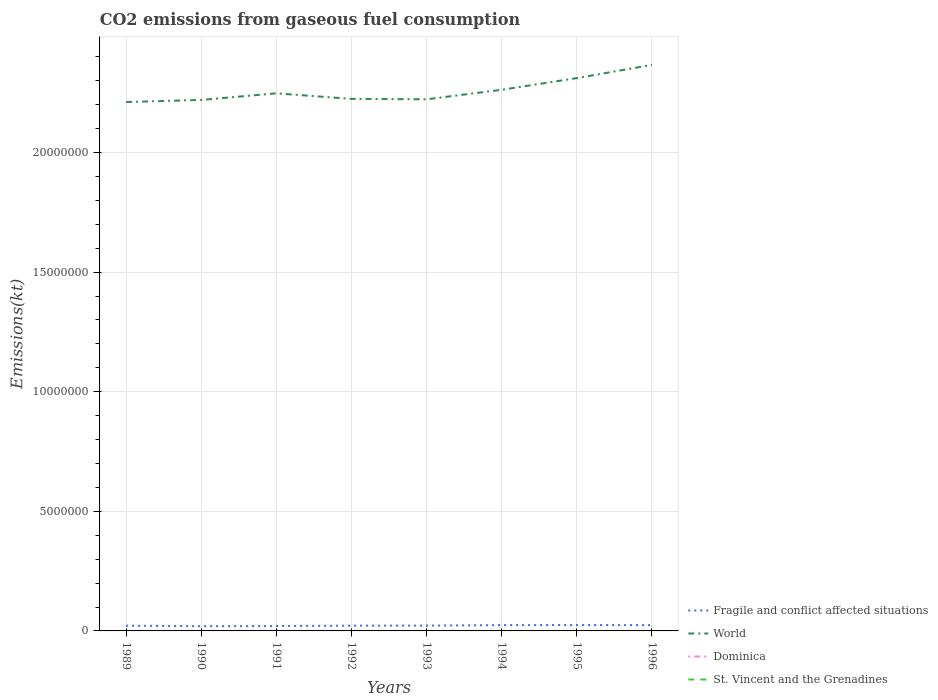How many different coloured lines are there?
Keep it short and to the point. 4. Across all years, what is the maximum amount of CO2 emitted in St. Vincent and the Grenadines?
Provide a short and direct response. 77.01. What is the difference between the highest and the second highest amount of CO2 emitted in Fragile and conflict affected situations?
Your answer should be compact. 4.87e+04. Is the amount of CO2 emitted in Fragile and conflict affected situations strictly greater than the amount of CO2 emitted in World over the years?
Make the answer very short. Yes. How many lines are there?
Make the answer very short. 4. How many years are there in the graph?
Give a very brief answer. 8. How are the legend labels stacked?
Offer a very short reply. Vertical. What is the title of the graph?
Ensure brevity in your answer.  CO2 emissions from gaseous fuel consumption. Does "France" appear as one of the legend labels in the graph?
Your answer should be compact. No. What is the label or title of the X-axis?
Your answer should be very brief. Years. What is the label or title of the Y-axis?
Offer a very short reply. Emissions(kt). What is the Emissions(kt) in Fragile and conflict affected situations in 1989?
Offer a very short reply. 2.19e+05. What is the Emissions(kt) of World in 1989?
Ensure brevity in your answer.  2.21e+07. What is the Emissions(kt) in Dominica in 1989?
Ensure brevity in your answer.  58.67. What is the Emissions(kt) in St. Vincent and the Grenadines in 1989?
Ensure brevity in your answer.  77.01. What is the Emissions(kt) in Fragile and conflict affected situations in 1990?
Provide a short and direct response. 1.97e+05. What is the Emissions(kt) in World in 1990?
Your answer should be compact. 2.22e+07. What is the Emissions(kt) of Dominica in 1990?
Make the answer very short. 58.67. What is the Emissions(kt) of St. Vincent and the Grenadines in 1990?
Offer a terse response. 80.67. What is the Emissions(kt) of Fragile and conflict affected situations in 1991?
Offer a terse response. 2.04e+05. What is the Emissions(kt) of World in 1991?
Your response must be concise. 2.25e+07. What is the Emissions(kt) of Dominica in 1991?
Offer a very short reply. 58.67. What is the Emissions(kt) of St. Vincent and the Grenadines in 1991?
Keep it short and to the point. 77.01. What is the Emissions(kt) in Fragile and conflict affected situations in 1992?
Your answer should be very brief. 2.19e+05. What is the Emissions(kt) of World in 1992?
Make the answer very short. 2.22e+07. What is the Emissions(kt) in Dominica in 1992?
Offer a terse response. 58.67. What is the Emissions(kt) in St. Vincent and the Grenadines in 1992?
Give a very brief answer. 84.34. What is the Emissions(kt) in Fragile and conflict affected situations in 1993?
Your response must be concise. 2.22e+05. What is the Emissions(kt) in World in 1993?
Your response must be concise. 2.22e+07. What is the Emissions(kt) in Dominica in 1993?
Offer a terse response. 62.34. What is the Emissions(kt) of St. Vincent and the Grenadines in 1993?
Keep it short and to the point. 102.68. What is the Emissions(kt) of Fragile and conflict affected situations in 1994?
Your answer should be compact. 2.43e+05. What is the Emissions(kt) in World in 1994?
Keep it short and to the point. 2.26e+07. What is the Emissions(kt) in Dominica in 1994?
Give a very brief answer. 69.67. What is the Emissions(kt) in St. Vincent and the Grenadines in 1994?
Give a very brief answer. 121.01. What is the Emissions(kt) of Fragile and conflict affected situations in 1995?
Make the answer very short. 2.46e+05. What is the Emissions(kt) of World in 1995?
Your answer should be very brief. 2.31e+07. What is the Emissions(kt) in Dominica in 1995?
Provide a short and direct response. 80.67. What is the Emissions(kt) in St. Vincent and the Grenadines in 1995?
Your response must be concise. 128.34. What is the Emissions(kt) in Fragile and conflict affected situations in 1996?
Provide a succinct answer. 2.42e+05. What is the Emissions(kt) in World in 1996?
Provide a succinct answer. 2.37e+07. What is the Emissions(kt) in Dominica in 1996?
Provide a succinct answer. 73.34. What is the Emissions(kt) in St. Vincent and the Grenadines in 1996?
Keep it short and to the point. 132.01. Across all years, what is the maximum Emissions(kt) in Fragile and conflict affected situations?
Your response must be concise. 2.46e+05. Across all years, what is the maximum Emissions(kt) of World?
Your answer should be very brief. 2.37e+07. Across all years, what is the maximum Emissions(kt) of Dominica?
Your response must be concise. 80.67. Across all years, what is the maximum Emissions(kt) of St. Vincent and the Grenadines?
Offer a very short reply. 132.01. Across all years, what is the minimum Emissions(kt) of Fragile and conflict affected situations?
Give a very brief answer. 1.97e+05. Across all years, what is the minimum Emissions(kt) of World?
Make the answer very short. 2.21e+07. Across all years, what is the minimum Emissions(kt) in Dominica?
Ensure brevity in your answer.  58.67. Across all years, what is the minimum Emissions(kt) in St. Vincent and the Grenadines?
Offer a very short reply. 77.01. What is the total Emissions(kt) of Fragile and conflict affected situations in the graph?
Offer a very short reply. 1.79e+06. What is the total Emissions(kt) in World in the graph?
Provide a short and direct response. 1.81e+08. What is the total Emissions(kt) in Dominica in the graph?
Provide a succinct answer. 520.71. What is the total Emissions(kt) of St. Vincent and the Grenadines in the graph?
Your answer should be compact. 803.07. What is the difference between the Emissions(kt) of Fragile and conflict affected situations in 1989 and that in 1990?
Give a very brief answer. 2.20e+04. What is the difference between the Emissions(kt) in World in 1989 and that in 1990?
Make the answer very short. -8.86e+04. What is the difference between the Emissions(kt) in Dominica in 1989 and that in 1990?
Offer a terse response. 0. What is the difference between the Emissions(kt) of St. Vincent and the Grenadines in 1989 and that in 1990?
Offer a terse response. -3.67. What is the difference between the Emissions(kt) in Fragile and conflict affected situations in 1989 and that in 1991?
Your answer should be compact. 1.46e+04. What is the difference between the Emissions(kt) of World in 1989 and that in 1991?
Keep it short and to the point. -3.65e+05. What is the difference between the Emissions(kt) in Dominica in 1989 and that in 1991?
Keep it short and to the point. 0. What is the difference between the Emissions(kt) in St. Vincent and the Grenadines in 1989 and that in 1991?
Ensure brevity in your answer.  0. What is the difference between the Emissions(kt) in Fragile and conflict affected situations in 1989 and that in 1992?
Your answer should be compact. -659.5. What is the difference between the Emissions(kt) in World in 1989 and that in 1992?
Provide a short and direct response. -1.33e+05. What is the difference between the Emissions(kt) of Dominica in 1989 and that in 1992?
Your response must be concise. 0. What is the difference between the Emissions(kt) of St. Vincent and the Grenadines in 1989 and that in 1992?
Give a very brief answer. -7.33. What is the difference between the Emissions(kt) of Fragile and conflict affected situations in 1989 and that in 1993?
Give a very brief answer. -3215.98. What is the difference between the Emissions(kt) in World in 1989 and that in 1993?
Ensure brevity in your answer.  -1.15e+05. What is the difference between the Emissions(kt) of Dominica in 1989 and that in 1993?
Keep it short and to the point. -3.67. What is the difference between the Emissions(kt) of St. Vincent and the Grenadines in 1989 and that in 1993?
Keep it short and to the point. -25.67. What is the difference between the Emissions(kt) in Fragile and conflict affected situations in 1989 and that in 1994?
Give a very brief answer. -2.40e+04. What is the difference between the Emissions(kt) of World in 1989 and that in 1994?
Your response must be concise. -5.14e+05. What is the difference between the Emissions(kt) of Dominica in 1989 and that in 1994?
Offer a very short reply. -11. What is the difference between the Emissions(kt) of St. Vincent and the Grenadines in 1989 and that in 1994?
Offer a very short reply. -44. What is the difference between the Emissions(kt) of Fragile and conflict affected situations in 1989 and that in 1995?
Your answer should be compact. -2.67e+04. What is the difference between the Emissions(kt) of World in 1989 and that in 1995?
Your response must be concise. -1.00e+06. What is the difference between the Emissions(kt) of Dominica in 1989 and that in 1995?
Provide a succinct answer. -22. What is the difference between the Emissions(kt) in St. Vincent and the Grenadines in 1989 and that in 1995?
Ensure brevity in your answer.  -51.34. What is the difference between the Emissions(kt) in Fragile and conflict affected situations in 1989 and that in 1996?
Your answer should be very brief. -2.31e+04. What is the difference between the Emissions(kt) in World in 1989 and that in 1996?
Provide a short and direct response. -1.55e+06. What is the difference between the Emissions(kt) in Dominica in 1989 and that in 1996?
Offer a very short reply. -14.67. What is the difference between the Emissions(kt) of St. Vincent and the Grenadines in 1989 and that in 1996?
Make the answer very short. -55.01. What is the difference between the Emissions(kt) in Fragile and conflict affected situations in 1990 and that in 1991?
Make the answer very short. -7327.05. What is the difference between the Emissions(kt) in World in 1990 and that in 1991?
Make the answer very short. -2.76e+05. What is the difference between the Emissions(kt) of St. Vincent and the Grenadines in 1990 and that in 1991?
Provide a succinct answer. 3.67. What is the difference between the Emissions(kt) in Fragile and conflict affected situations in 1990 and that in 1992?
Offer a terse response. -2.26e+04. What is the difference between the Emissions(kt) of World in 1990 and that in 1992?
Make the answer very short. -4.44e+04. What is the difference between the Emissions(kt) in St. Vincent and the Grenadines in 1990 and that in 1992?
Make the answer very short. -3.67. What is the difference between the Emissions(kt) in Fragile and conflict affected situations in 1990 and that in 1993?
Offer a terse response. -2.52e+04. What is the difference between the Emissions(kt) in World in 1990 and that in 1993?
Ensure brevity in your answer.  -2.67e+04. What is the difference between the Emissions(kt) in Dominica in 1990 and that in 1993?
Provide a short and direct response. -3.67. What is the difference between the Emissions(kt) of St. Vincent and the Grenadines in 1990 and that in 1993?
Give a very brief answer. -22. What is the difference between the Emissions(kt) of Fragile and conflict affected situations in 1990 and that in 1994?
Provide a short and direct response. -4.60e+04. What is the difference between the Emissions(kt) of World in 1990 and that in 1994?
Your answer should be very brief. -4.25e+05. What is the difference between the Emissions(kt) of Dominica in 1990 and that in 1994?
Keep it short and to the point. -11. What is the difference between the Emissions(kt) in St. Vincent and the Grenadines in 1990 and that in 1994?
Your answer should be very brief. -40.34. What is the difference between the Emissions(kt) in Fragile and conflict affected situations in 1990 and that in 1995?
Your answer should be compact. -4.87e+04. What is the difference between the Emissions(kt) of World in 1990 and that in 1995?
Keep it short and to the point. -9.13e+05. What is the difference between the Emissions(kt) in Dominica in 1990 and that in 1995?
Provide a succinct answer. -22. What is the difference between the Emissions(kt) of St. Vincent and the Grenadines in 1990 and that in 1995?
Ensure brevity in your answer.  -47.67. What is the difference between the Emissions(kt) of Fragile and conflict affected situations in 1990 and that in 1996?
Your answer should be very brief. -4.50e+04. What is the difference between the Emissions(kt) in World in 1990 and that in 1996?
Offer a very short reply. -1.47e+06. What is the difference between the Emissions(kt) in Dominica in 1990 and that in 1996?
Make the answer very short. -14.67. What is the difference between the Emissions(kt) in St. Vincent and the Grenadines in 1990 and that in 1996?
Your answer should be very brief. -51.34. What is the difference between the Emissions(kt) in Fragile and conflict affected situations in 1991 and that in 1992?
Provide a short and direct response. -1.53e+04. What is the difference between the Emissions(kt) in World in 1991 and that in 1992?
Provide a succinct answer. 2.32e+05. What is the difference between the Emissions(kt) in St. Vincent and the Grenadines in 1991 and that in 1992?
Provide a succinct answer. -7.33. What is the difference between the Emissions(kt) in Fragile and conflict affected situations in 1991 and that in 1993?
Keep it short and to the point. -1.79e+04. What is the difference between the Emissions(kt) in World in 1991 and that in 1993?
Your response must be concise. 2.49e+05. What is the difference between the Emissions(kt) in Dominica in 1991 and that in 1993?
Your answer should be compact. -3.67. What is the difference between the Emissions(kt) in St. Vincent and the Grenadines in 1991 and that in 1993?
Provide a short and direct response. -25.67. What is the difference between the Emissions(kt) in Fragile and conflict affected situations in 1991 and that in 1994?
Make the answer very short. -3.86e+04. What is the difference between the Emissions(kt) in World in 1991 and that in 1994?
Your answer should be very brief. -1.49e+05. What is the difference between the Emissions(kt) of Dominica in 1991 and that in 1994?
Ensure brevity in your answer.  -11. What is the difference between the Emissions(kt) in St. Vincent and the Grenadines in 1991 and that in 1994?
Your answer should be very brief. -44. What is the difference between the Emissions(kt) in Fragile and conflict affected situations in 1991 and that in 1995?
Keep it short and to the point. -4.14e+04. What is the difference between the Emissions(kt) in World in 1991 and that in 1995?
Give a very brief answer. -6.37e+05. What is the difference between the Emissions(kt) of Dominica in 1991 and that in 1995?
Your answer should be compact. -22. What is the difference between the Emissions(kt) of St. Vincent and the Grenadines in 1991 and that in 1995?
Provide a succinct answer. -51.34. What is the difference between the Emissions(kt) in Fragile and conflict affected situations in 1991 and that in 1996?
Your answer should be compact. -3.77e+04. What is the difference between the Emissions(kt) of World in 1991 and that in 1996?
Your answer should be very brief. -1.19e+06. What is the difference between the Emissions(kt) in Dominica in 1991 and that in 1996?
Offer a terse response. -14.67. What is the difference between the Emissions(kt) in St. Vincent and the Grenadines in 1991 and that in 1996?
Keep it short and to the point. -55.01. What is the difference between the Emissions(kt) of Fragile and conflict affected situations in 1992 and that in 1993?
Ensure brevity in your answer.  -2556.47. What is the difference between the Emissions(kt) in World in 1992 and that in 1993?
Keep it short and to the point. 1.77e+04. What is the difference between the Emissions(kt) of Dominica in 1992 and that in 1993?
Your answer should be compact. -3.67. What is the difference between the Emissions(kt) in St. Vincent and the Grenadines in 1992 and that in 1993?
Give a very brief answer. -18.34. What is the difference between the Emissions(kt) in Fragile and conflict affected situations in 1992 and that in 1994?
Give a very brief answer. -2.33e+04. What is the difference between the Emissions(kt) of World in 1992 and that in 1994?
Ensure brevity in your answer.  -3.81e+05. What is the difference between the Emissions(kt) in Dominica in 1992 and that in 1994?
Provide a short and direct response. -11. What is the difference between the Emissions(kt) in St. Vincent and the Grenadines in 1992 and that in 1994?
Your answer should be compact. -36.67. What is the difference between the Emissions(kt) in Fragile and conflict affected situations in 1992 and that in 1995?
Your response must be concise. -2.61e+04. What is the difference between the Emissions(kt) of World in 1992 and that in 1995?
Keep it short and to the point. -8.69e+05. What is the difference between the Emissions(kt) of Dominica in 1992 and that in 1995?
Make the answer very short. -22. What is the difference between the Emissions(kt) in St. Vincent and the Grenadines in 1992 and that in 1995?
Offer a very short reply. -44. What is the difference between the Emissions(kt) of Fragile and conflict affected situations in 1992 and that in 1996?
Offer a terse response. -2.24e+04. What is the difference between the Emissions(kt) in World in 1992 and that in 1996?
Make the answer very short. -1.42e+06. What is the difference between the Emissions(kt) in Dominica in 1992 and that in 1996?
Provide a short and direct response. -14.67. What is the difference between the Emissions(kt) in St. Vincent and the Grenadines in 1992 and that in 1996?
Offer a very short reply. -47.67. What is the difference between the Emissions(kt) of Fragile and conflict affected situations in 1993 and that in 1994?
Give a very brief answer. -2.08e+04. What is the difference between the Emissions(kt) in World in 1993 and that in 1994?
Give a very brief answer. -3.99e+05. What is the difference between the Emissions(kt) of Dominica in 1993 and that in 1994?
Offer a very short reply. -7.33. What is the difference between the Emissions(kt) in St. Vincent and the Grenadines in 1993 and that in 1994?
Offer a very short reply. -18.34. What is the difference between the Emissions(kt) of Fragile and conflict affected situations in 1993 and that in 1995?
Offer a terse response. -2.35e+04. What is the difference between the Emissions(kt) in World in 1993 and that in 1995?
Your answer should be compact. -8.87e+05. What is the difference between the Emissions(kt) of Dominica in 1993 and that in 1995?
Your response must be concise. -18.34. What is the difference between the Emissions(kt) of St. Vincent and the Grenadines in 1993 and that in 1995?
Provide a succinct answer. -25.67. What is the difference between the Emissions(kt) in Fragile and conflict affected situations in 1993 and that in 1996?
Your response must be concise. -1.99e+04. What is the difference between the Emissions(kt) in World in 1993 and that in 1996?
Your response must be concise. -1.44e+06. What is the difference between the Emissions(kt) of Dominica in 1993 and that in 1996?
Provide a short and direct response. -11. What is the difference between the Emissions(kt) of St. Vincent and the Grenadines in 1993 and that in 1996?
Make the answer very short. -29.34. What is the difference between the Emissions(kt) of Fragile and conflict affected situations in 1994 and that in 1995?
Provide a succinct answer. -2730.08. What is the difference between the Emissions(kt) of World in 1994 and that in 1995?
Offer a very short reply. -4.88e+05. What is the difference between the Emissions(kt) in Dominica in 1994 and that in 1995?
Your answer should be compact. -11. What is the difference between the Emissions(kt) of St. Vincent and the Grenadines in 1994 and that in 1995?
Provide a succinct answer. -7.33. What is the difference between the Emissions(kt) in Fragile and conflict affected situations in 1994 and that in 1996?
Give a very brief answer. 925.17. What is the difference between the Emissions(kt) of World in 1994 and that in 1996?
Keep it short and to the point. -1.04e+06. What is the difference between the Emissions(kt) in Dominica in 1994 and that in 1996?
Offer a terse response. -3.67. What is the difference between the Emissions(kt) in St. Vincent and the Grenadines in 1994 and that in 1996?
Your answer should be compact. -11. What is the difference between the Emissions(kt) in Fragile and conflict affected situations in 1995 and that in 1996?
Your answer should be compact. 3655.26. What is the difference between the Emissions(kt) of World in 1995 and that in 1996?
Provide a succinct answer. -5.53e+05. What is the difference between the Emissions(kt) of Dominica in 1995 and that in 1996?
Your answer should be compact. 7.33. What is the difference between the Emissions(kt) in St. Vincent and the Grenadines in 1995 and that in 1996?
Provide a succinct answer. -3.67. What is the difference between the Emissions(kt) of Fragile and conflict affected situations in 1989 and the Emissions(kt) of World in 1990?
Make the answer very short. -2.20e+07. What is the difference between the Emissions(kt) in Fragile and conflict affected situations in 1989 and the Emissions(kt) in Dominica in 1990?
Keep it short and to the point. 2.19e+05. What is the difference between the Emissions(kt) of Fragile and conflict affected situations in 1989 and the Emissions(kt) of St. Vincent and the Grenadines in 1990?
Keep it short and to the point. 2.19e+05. What is the difference between the Emissions(kt) of World in 1989 and the Emissions(kt) of Dominica in 1990?
Give a very brief answer. 2.21e+07. What is the difference between the Emissions(kt) in World in 1989 and the Emissions(kt) in St. Vincent and the Grenadines in 1990?
Keep it short and to the point. 2.21e+07. What is the difference between the Emissions(kt) of Dominica in 1989 and the Emissions(kt) of St. Vincent and the Grenadines in 1990?
Your response must be concise. -22. What is the difference between the Emissions(kt) in Fragile and conflict affected situations in 1989 and the Emissions(kt) in World in 1991?
Ensure brevity in your answer.  -2.23e+07. What is the difference between the Emissions(kt) in Fragile and conflict affected situations in 1989 and the Emissions(kt) in Dominica in 1991?
Your answer should be very brief. 2.19e+05. What is the difference between the Emissions(kt) in Fragile and conflict affected situations in 1989 and the Emissions(kt) in St. Vincent and the Grenadines in 1991?
Give a very brief answer. 2.19e+05. What is the difference between the Emissions(kt) of World in 1989 and the Emissions(kt) of Dominica in 1991?
Your response must be concise. 2.21e+07. What is the difference between the Emissions(kt) in World in 1989 and the Emissions(kt) in St. Vincent and the Grenadines in 1991?
Your response must be concise. 2.21e+07. What is the difference between the Emissions(kt) of Dominica in 1989 and the Emissions(kt) of St. Vincent and the Grenadines in 1991?
Give a very brief answer. -18.34. What is the difference between the Emissions(kt) in Fragile and conflict affected situations in 1989 and the Emissions(kt) in World in 1992?
Ensure brevity in your answer.  -2.20e+07. What is the difference between the Emissions(kt) of Fragile and conflict affected situations in 1989 and the Emissions(kt) of Dominica in 1992?
Keep it short and to the point. 2.19e+05. What is the difference between the Emissions(kt) in Fragile and conflict affected situations in 1989 and the Emissions(kt) in St. Vincent and the Grenadines in 1992?
Ensure brevity in your answer.  2.19e+05. What is the difference between the Emissions(kt) of World in 1989 and the Emissions(kt) of Dominica in 1992?
Provide a short and direct response. 2.21e+07. What is the difference between the Emissions(kt) in World in 1989 and the Emissions(kt) in St. Vincent and the Grenadines in 1992?
Provide a succinct answer. 2.21e+07. What is the difference between the Emissions(kt) in Dominica in 1989 and the Emissions(kt) in St. Vincent and the Grenadines in 1992?
Your response must be concise. -25.67. What is the difference between the Emissions(kt) of Fragile and conflict affected situations in 1989 and the Emissions(kt) of World in 1993?
Keep it short and to the point. -2.20e+07. What is the difference between the Emissions(kt) of Fragile and conflict affected situations in 1989 and the Emissions(kt) of Dominica in 1993?
Give a very brief answer. 2.19e+05. What is the difference between the Emissions(kt) in Fragile and conflict affected situations in 1989 and the Emissions(kt) in St. Vincent and the Grenadines in 1993?
Your answer should be very brief. 2.19e+05. What is the difference between the Emissions(kt) of World in 1989 and the Emissions(kt) of Dominica in 1993?
Offer a terse response. 2.21e+07. What is the difference between the Emissions(kt) in World in 1989 and the Emissions(kt) in St. Vincent and the Grenadines in 1993?
Your response must be concise. 2.21e+07. What is the difference between the Emissions(kt) in Dominica in 1989 and the Emissions(kt) in St. Vincent and the Grenadines in 1993?
Your answer should be very brief. -44. What is the difference between the Emissions(kt) of Fragile and conflict affected situations in 1989 and the Emissions(kt) of World in 1994?
Your response must be concise. -2.24e+07. What is the difference between the Emissions(kt) of Fragile and conflict affected situations in 1989 and the Emissions(kt) of Dominica in 1994?
Offer a terse response. 2.19e+05. What is the difference between the Emissions(kt) in Fragile and conflict affected situations in 1989 and the Emissions(kt) in St. Vincent and the Grenadines in 1994?
Ensure brevity in your answer.  2.19e+05. What is the difference between the Emissions(kt) of World in 1989 and the Emissions(kt) of Dominica in 1994?
Offer a terse response. 2.21e+07. What is the difference between the Emissions(kt) of World in 1989 and the Emissions(kt) of St. Vincent and the Grenadines in 1994?
Provide a succinct answer. 2.21e+07. What is the difference between the Emissions(kt) in Dominica in 1989 and the Emissions(kt) in St. Vincent and the Grenadines in 1994?
Your answer should be very brief. -62.34. What is the difference between the Emissions(kt) in Fragile and conflict affected situations in 1989 and the Emissions(kt) in World in 1995?
Give a very brief answer. -2.29e+07. What is the difference between the Emissions(kt) in Fragile and conflict affected situations in 1989 and the Emissions(kt) in Dominica in 1995?
Provide a short and direct response. 2.19e+05. What is the difference between the Emissions(kt) in Fragile and conflict affected situations in 1989 and the Emissions(kt) in St. Vincent and the Grenadines in 1995?
Provide a succinct answer. 2.19e+05. What is the difference between the Emissions(kt) in World in 1989 and the Emissions(kt) in Dominica in 1995?
Make the answer very short. 2.21e+07. What is the difference between the Emissions(kt) of World in 1989 and the Emissions(kt) of St. Vincent and the Grenadines in 1995?
Keep it short and to the point. 2.21e+07. What is the difference between the Emissions(kt) in Dominica in 1989 and the Emissions(kt) in St. Vincent and the Grenadines in 1995?
Ensure brevity in your answer.  -69.67. What is the difference between the Emissions(kt) of Fragile and conflict affected situations in 1989 and the Emissions(kt) of World in 1996?
Offer a terse response. -2.34e+07. What is the difference between the Emissions(kt) in Fragile and conflict affected situations in 1989 and the Emissions(kt) in Dominica in 1996?
Offer a very short reply. 2.19e+05. What is the difference between the Emissions(kt) of Fragile and conflict affected situations in 1989 and the Emissions(kt) of St. Vincent and the Grenadines in 1996?
Make the answer very short. 2.19e+05. What is the difference between the Emissions(kt) in World in 1989 and the Emissions(kt) in Dominica in 1996?
Give a very brief answer. 2.21e+07. What is the difference between the Emissions(kt) of World in 1989 and the Emissions(kt) of St. Vincent and the Grenadines in 1996?
Your answer should be compact. 2.21e+07. What is the difference between the Emissions(kt) in Dominica in 1989 and the Emissions(kt) in St. Vincent and the Grenadines in 1996?
Keep it short and to the point. -73.34. What is the difference between the Emissions(kt) of Fragile and conflict affected situations in 1990 and the Emissions(kt) of World in 1991?
Your response must be concise. -2.23e+07. What is the difference between the Emissions(kt) in Fragile and conflict affected situations in 1990 and the Emissions(kt) in Dominica in 1991?
Your response must be concise. 1.97e+05. What is the difference between the Emissions(kt) in Fragile and conflict affected situations in 1990 and the Emissions(kt) in St. Vincent and the Grenadines in 1991?
Your response must be concise. 1.97e+05. What is the difference between the Emissions(kt) of World in 1990 and the Emissions(kt) of Dominica in 1991?
Offer a terse response. 2.22e+07. What is the difference between the Emissions(kt) in World in 1990 and the Emissions(kt) in St. Vincent and the Grenadines in 1991?
Provide a short and direct response. 2.22e+07. What is the difference between the Emissions(kt) in Dominica in 1990 and the Emissions(kt) in St. Vincent and the Grenadines in 1991?
Your response must be concise. -18.34. What is the difference between the Emissions(kt) of Fragile and conflict affected situations in 1990 and the Emissions(kt) of World in 1992?
Ensure brevity in your answer.  -2.20e+07. What is the difference between the Emissions(kt) of Fragile and conflict affected situations in 1990 and the Emissions(kt) of Dominica in 1992?
Keep it short and to the point. 1.97e+05. What is the difference between the Emissions(kt) of Fragile and conflict affected situations in 1990 and the Emissions(kt) of St. Vincent and the Grenadines in 1992?
Your response must be concise. 1.97e+05. What is the difference between the Emissions(kt) of World in 1990 and the Emissions(kt) of Dominica in 1992?
Provide a succinct answer. 2.22e+07. What is the difference between the Emissions(kt) of World in 1990 and the Emissions(kt) of St. Vincent and the Grenadines in 1992?
Offer a terse response. 2.22e+07. What is the difference between the Emissions(kt) in Dominica in 1990 and the Emissions(kt) in St. Vincent and the Grenadines in 1992?
Offer a very short reply. -25.67. What is the difference between the Emissions(kt) of Fragile and conflict affected situations in 1990 and the Emissions(kt) of World in 1993?
Your answer should be very brief. -2.20e+07. What is the difference between the Emissions(kt) of Fragile and conflict affected situations in 1990 and the Emissions(kt) of Dominica in 1993?
Your answer should be compact. 1.97e+05. What is the difference between the Emissions(kt) in Fragile and conflict affected situations in 1990 and the Emissions(kt) in St. Vincent and the Grenadines in 1993?
Your response must be concise. 1.97e+05. What is the difference between the Emissions(kt) in World in 1990 and the Emissions(kt) in Dominica in 1993?
Ensure brevity in your answer.  2.22e+07. What is the difference between the Emissions(kt) of World in 1990 and the Emissions(kt) of St. Vincent and the Grenadines in 1993?
Your response must be concise. 2.22e+07. What is the difference between the Emissions(kt) of Dominica in 1990 and the Emissions(kt) of St. Vincent and the Grenadines in 1993?
Your response must be concise. -44. What is the difference between the Emissions(kt) of Fragile and conflict affected situations in 1990 and the Emissions(kt) of World in 1994?
Provide a short and direct response. -2.24e+07. What is the difference between the Emissions(kt) of Fragile and conflict affected situations in 1990 and the Emissions(kt) of Dominica in 1994?
Offer a terse response. 1.97e+05. What is the difference between the Emissions(kt) in Fragile and conflict affected situations in 1990 and the Emissions(kt) in St. Vincent and the Grenadines in 1994?
Make the answer very short. 1.97e+05. What is the difference between the Emissions(kt) in World in 1990 and the Emissions(kt) in Dominica in 1994?
Your answer should be compact. 2.22e+07. What is the difference between the Emissions(kt) in World in 1990 and the Emissions(kt) in St. Vincent and the Grenadines in 1994?
Provide a succinct answer. 2.22e+07. What is the difference between the Emissions(kt) in Dominica in 1990 and the Emissions(kt) in St. Vincent and the Grenadines in 1994?
Provide a succinct answer. -62.34. What is the difference between the Emissions(kt) of Fragile and conflict affected situations in 1990 and the Emissions(kt) of World in 1995?
Your answer should be compact. -2.29e+07. What is the difference between the Emissions(kt) of Fragile and conflict affected situations in 1990 and the Emissions(kt) of Dominica in 1995?
Make the answer very short. 1.97e+05. What is the difference between the Emissions(kt) in Fragile and conflict affected situations in 1990 and the Emissions(kt) in St. Vincent and the Grenadines in 1995?
Offer a terse response. 1.97e+05. What is the difference between the Emissions(kt) of World in 1990 and the Emissions(kt) of Dominica in 1995?
Offer a very short reply. 2.22e+07. What is the difference between the Emissions(kt) in World in 1990 and the Emissions(kt) in St. Vincent and the Grenadines in 1995?
Your response must be concise. 2.22e+07. What is the difference between the Emissions(kt) of Dominica in 1990 and the Emissions(kt) of St. Vincent and the Grenadines in 1995?
Ensure brevity in your answer.  -69.67. What is the difference between the Emissions(kt) of Fragile and conflict affected situations in 1990 and the Emissions(kt) of World in 1996?
Your response must be concise. -2.35e+07. What is the difference between the Emissions(kt) in Fragile and conflict affected situations in 1990 and the Emissions(kt) in Dominica in 1996?
Your answer should be compact. 1.97e+05. What is the difference between the Emissions(kt) in Fragile and conflict affected situations in 1990 and the Emissions(kt) in St. Vincent and the Grenadines in 1996?
Offer a very short reply. 1.97e+05. What is the difference between the Emissions(kt) in World in 1990 and the Emissions(kt) in Dominica in 1996?
Your response must be concise. 2.22e+07. What is the difference between the Emissions(kt) of World in 1990 and the Emissions(kt) of St. Vincent and the Grenadines in 1996?
Keep it short and to the point. 2.22e+07. What is the difference between the Emissions(kt) in Dominica in 1990 and the Emissions(kt) in St. Vincent and the Grenadines in 1996?
Offer a very short reply. -73.34. What is the difference between the Emissions(kt) of Fragile and conflict affected situations in 1991 and the Emissions(kt) of World in 1992?
Offer a terse response. -2.20e+07. What is the difference between the Emissions(kt) of Fragile and conflict affected situations in 1991 and the Emissions(kt) of Dominica in 1992?
Your response must be concise. 2.04e+05. What is the difference between the Emissions(kt) of Fragile and conflict affected situations in 1991 and the Emissions(kt) of St. Vincent and the Grenadines in 1992?
Provide a succinct answer. 2.04e+05. What is the difference between the Emissions(kt) of World in 1991 and the Emissions(kt) of Dominica in 1992?
Provide a succinct answer. 2.25e+07. What is the difference between the Emissions(kt) in World in 1991 and the Emissions(kt) in St. Vincent and the Grenadines in 1992?
Offer a very short reply. 2.25e+07. What is the difference between the Emissions(kt) in Dominica in 1991 and the Emissions(kt) in St. Vincent and the Grenadines in 1992?
Make the answer very short. -25.67. What is the difference between the Emissions(kt) in Fragile and conflict affected situations in 1991 and the Emissions(kt) in World in 1993?
Provide a short and direct response. -2.20e+07. What is the difference between the Emissions(kt) in Fragile and conflict affected situations in 1991 and the Emissions(kt) in Dominica in 1993?
Your answer should be very brief. 2.04e+05. What is the difference between the Emissions(kt) of Fragile and conflict affected situations in 1991 and the Emissions(kt) of St. Vincent and the Grenadines in 1993?
Offer a very short reply. 2.04e+05. What is the difference between the Emissions(kt) in World in 1991 and the Emissions(kt) in Dominica in 1993?
Offer a terse response. 2.25e+07. What is the difference between the Emissions(kt) in World in 1991 and the Emissions(kt) in St. Vincent and the Grenadines in 1993?
Ensure brevity in your answer.  2.25e+07. What is the difference between the Emissions(kt) of Dominica in 1991 and the Emissions(kt) of St. Vincent and the Grenadines in 1993?
Your response must be concise. -44. What is the difference between the Emissions(kt) of Fragile and conflict affected situations in 1991 and the Emissions(kt) of World in 1994?
Ensure brevity in your answer.  -2.24e+07. What is the difference between the Emissions(kt) in Fragile and conflict affected situations in 1991 and the Emissions(kt) in Dominica in 1994?
Your response must be concise. 2.04e+05. What is the difference between the Emissions(kt) of Fragile and conflict affected situations in 1991 and the Emissions(kt) of St. Vincent and the Grenadines in 1994?
Offer a terse response. 2.04e+05. What is the difference between the Emissions(kt) of World in 1991 and the Emissions(kt) of Dominica in 1994?
Make the answer very short. 2.25e+07. What is the difference between the Emissions(kt) in World in 1991 and the Emissions(kt) in St. Vincent and the Grenadines in 1994?
Ensure brevity in your answer.  2.25e+07. What is the difference between the Emissions(kt) in Dominica in 1991 and the Emissions(kt) in St. Vincent and the Grenadines in 1994?
Keep it short and to the point. -62.34. What is the difference between the Emissions(kt) of Fragile and conflict affected situations in 1991 and the Emissions(kt) of World in 1995?
Your answer should be compact. -2.29e+07. What is the difference between the Emissions(kt) of Fragile and conflict affected situations in 1991 and the Emissions(kt) of Dominica in 1995?
Give a very brief answer. 2.04e+05. What is the difference between the Emissions(kt) of Fragile and conflict affected situations in 1991 and the Emissions(kt) of St. Vincent and the Grenadines in 1995?
Ensure brevity in your answer.  2.04e+05. What is the difference between the Emissions(kt) of World in 1991 and the Emissions(kt) of Dominica in 1995?
Your answer should be compact. 2.25e+07. What is the difference between the Emissions(kt) in World in 1991 and the Emissions(kt) in St. Vincent and the Grenadines in 1995?
Keep it short and to the point. 2.25e+07. What is the difference between the Emissions(kt) in Dominica in 1991 and the Emissions(kt) in St. Vincent and the Grenadines in 1995?
Give a very brief answer. -69.67. What is the difference between the Emissions(kt) in Fragile and conflict affected situations in 1991 and the Emissions(kt) in World in 1996?
Keep it short and to the point. -2.35e+07. What is the difference between the Emissions(kt) in Fragile and conflict affected situations in 1991 and the Emissions(kt) in Dominica in 1996?
Your answer should be compact. 2.04e+05. What is the difference between the Emissions(kt) of Fragile and conflict affected situations in 1991 and the Emissions(kt) of St. Vincent and the Grenadines in 1996?
Give a very brief answer. 2.04e+05. What is the difference between the Emissions(kt) of World in 1991 and the Emissions(kt) of Dominica in 1996?
Offer a very short reply. 2.25e+07. What is the difference between the Emissions(kt) in World in 1991 and the Emissions(kt) in St. Vincent and the Grenadines in 1996?
Your response must be concise. 2.25e+07. What is the difference between the Emissions(kt) in Dominica in 1991 and the Emissions(kt) in St. Vincent and the Grenadines in 1996?
Provide a short and direct response. -73.34. What is the difference between the Emissions(kt) of Fragile and conflict affected situations in 1992 and the Emissions(kt) of World in 1993?
Your response must be concise. -2.20e+07. What is the difference between the Emissions(kt) of Fragile and conflict affected situations in 1992 and the Emissions(kt) of Dominica in 1993?
Offer a terse response. 2.19e+05. What is the difference between the Emissions(kt) in Fragile and conflict affected situations in 1992 and the Emissions(kt) in St. Vincent and the Grenadines in 1993?
Keep it short and to the point. 2.19e+05. What is the difference between the Emissions(kt) of World in 1992 and the Emissions(kt) of Dominica in 1993?
Offer a terse response. 2.22e+07. What is the difference between the Emissions(kt) of World in 1992 and the Emissions(kt) of St. Vincent and the Grenadines in 1993?
Offer a terse response. 2.22e+07. What is the difference between the Emissions(kt) of Dominica in 1992 and the Emissions(kt) of St. Vincent and the Grenadines in 1993?
Offer a very short reply. -44. What is the difference between the Emissions(kt) in Fragile and conflict affected situations in 1992 and the Emissions(kt) in World in 1994?
Your answer should be very brief. -2.24e+07. What is the difference between the Emissions(kt) in Fragile and conflict affected situations in 1992 and the Emissions(kt) in Dominica in 1994?
Your answer should be very brief. 2.19e+05. What is the difference between the Emissions(kt) of Fragile and conflict affected situations in 1992 and the Emissions(kt) of St. Vincent and the Grenadines in 1994?
Provide a short and direct response. 2.19e+05. What is the difference between the Emissions(kt) in World in 1992 and the Emissions(kt) in Dominica in 1994?
Your response must be concise. 2.22e+07. What is the difference between the Emissions(kt) of World in 1992 and the Emissions(kt) of St. Vincent and the Grenadines in 1994?
Make the answer very short. 2.22e+07. What is the difference between the Emissions(kt) of Dominica in 1992 and the Emissions(kt) of St. Vincent and the Grenadines in 1994?
Give a very brief answer. -62.34. What is the difference between the Emissions(kt) of Fragile and conflict affected situations in 1992 and the Emissions(kt) of World in 1995?
Keep it short and to the point. -2.29e+07. What is the difference between the Emissions(kt) of Fragile and conflict affected situations in 1992 and the Emissions(kt) of Dominica in 1995?
Your response must be concise. 2.19e+05. What is the difference between the Emissions(kt) in Fragile and conflict affected situations in 1992 and the Emissions(kt) in St. Vincent and the Grenadines in 1995?
Your response must be concise. 2.19e+05. What is the difference between the Emissions(kt) in World in 1992 and the Emissions(kt) in Dominica in 1995?
Offer a terse response. 2.22e+07. What is the difference between the Emissions(kt) in World in 1992 and the Emissions(kt) in St. Vincent and the Grenadines in 1995?
Your answer should be compact. 2.22e+07. What is the difference between the Emissions(kt) in Dominica in 1992 and the Emissions(kt) in St. Vincent and the Grenadines in 1995?
Keep it short and to the point. -69.67. What is the difference between the Emissions(kt) in Fragile and conflict affected situations in 1992 and the Emissions(kt) in World in 1996?
Your answer should be very brief. -2.34e+07. What is the difference between the Emissions(kt) in Fragile and conflict affected situations in 1992 and the Emissions(kt) in Dominica in 1996?
Provide a succinct answer. 2.19e+05. What is the difference between the Emissions(kt) in Fragile and conflict affected situations in 1992 and the Emissions(kt) in St. Vincent and the Grenadines in 1996?
Give a very brief answer. 2.19e+05. What is the difference between the Emissions(kt) in World in 1992 and the Emissions(kt) in Dominica in 1996?
Your answer should be very brief. 2.22e+07. What is the difference between the Emissions(kt) in World in 1992 and the Emissions(kt) in St. Vincent and the Grenadines in 1996?
Ensure brevity in your answer.  2.22e+07. What is the difference between the Emissions(kt) in Dominica in 1992 and the Emissions(kt) in St. Vincent and the Grenadines in 1996?
Provide a succinct answer. -73.34. What is the difference between the Emissions(kt) of Fragile and conflict affected situations in 1993 and the Emissions(kt) of World in 1994?
Your response must be concise. -2.24e+07. What is the difference between the Emissions(kt) in Fragile and conflict affected situations in 1993 and the Emissions(kt) in Dominica in 1994?
Ensure brevity in your answer.  2.22e+05. What is the difference between the Emissions(kt) of Fragile and conflict affected situations in 1993 and the Emissions(kt) of St. Vincent and the Grenadines in 1994?
Provide a short and direct response. 2.22e+05. What is the difference between the Emissions(kt) in World in 1993 and the Emissions(kt) in Dominica in 1994?
Give a very brief answer. 2.22e+07. What is the difference between the Emissions(kt) in World in 1993 and the Emissions(kt) in St. Vincent and the Grenadines in 1994?
Your response must be concise. 2.22e+07. What is the difference between the Emissions(kt) of Dominica in 1993 and the Emissions(kt) of St. Vincent and the Grenadines in 1994?
Make the answer very short. -58.67. What is the difference between the Emissions(kt) of Fragile and conflict affected situations in 1993 and the Emissions(kt) of World in 1995?
Give a very brief answer. -2.29e+07. What is the difference between the Emissions(kt) in Fragile and conflict affected situations in 1993 and the Emissions(kt) in Dominica in 1995?
Provide a succinct answer. 2.22e+05. What is the difference between the Emissions(kt) of Fragile and conflict affected situations in 1993 and the Emissions(kt) of St. Vincent and the Grenadines in 1995?
Give a very brief answer. 2.22e+05. What is the difference between the Emissions(kt) of World in 1993 and the Emissions(kt) of Dominica in 1995?
Give a very brief answer. 2.22e+07. What is the difference between the Emissions(kt) of World in 1993 and the Emissions(kt) of St. Vincent and the Grenadines in 1995?
Provide a short and direct response. 2.22e+07. What is the difference between the Emissions(kt) in Dominica in 1993 and the Emissions(kt) in St. Vincent and the Grenadines in 1995?
Ensure brevity in your answer.  -66.01. What is the difference between the Emissions(kt) of Fragile and conflict affected situations in 1993 and the Emissions(kt) of World in 1996?
Provide a succinct answer. -2.34e+07. What is the difference between the Emissions(kt) in Fragile and conflict affected situations in 1993 and the Emissions(kt) in Dominica in 1996?
Give a very brief answer. 2.22e+05. What is the difference between the Emissions(kt) of Fragile and conflict affected situations in 1993 and the Emissions(kt) of St. Vincent and the Grenadines in 1996?
Your answer should be very brief. 2.22e+05. What is the difference between the Emissions(kt) in World in 1993 and the Emissions(kt) in Dominica in 1996?
Provide a short and direct response. 2.22e+07. What is the difference between the Emissions(kt) in World in 1993 and the Emissions(kt) in St. Vincent and the Grenadines in 1996?
Provide a succinct answer. 2.22e+07. What is the difference between the Emissions(kt) of Dominica in 1993 and the Emissions(kt) of St. Vincent and the Grenadines in 1996?
Your response must be concise. -69.67. What is the difference between the Emissions(kt) of Fragile and conflict affected situations in 1994 and the Emissions(kt) of World in 1995?
Your answer should be very brief. -2.29e+07. What is the difference between the Emissions(kt) of Fragile and conflict affected situations in 1994 and the Emissions(kt) of Dominica in 1995?
Your answer should be compact. 2.43e+05. What is the difference between the Emissions(kt) of Fragile and conflict affected situations in 1994 and the Emissions(kt) of St. Vincent and the Grenadines in 1995?
Offer a very short reply. 2.43e+05. What is the difference between the Emissions(kt) in World in 1994 and the Emissions(kt) in Dominica in 1995?
Your answer should be very brief. 2.26e+07. What is the difference between the Emissions(kt) of World in 1994 and the Emissions(kt) of St. Vincent and the Grenadines in 1995?
Your answer should be very brief. 2.26e+07. What is the difference between the Emissions(kt) in Dominica in 1994 and the Emissions(kt) in St. Vincent and the Grenadines in 1995?
Make the answer very short. -58.67. What is the difference between the Emissions(kt) in Fragile and conflict affected situations in 1994 and the Emissions(kt) in World in 1996?
Provide a succinct answer. -2.34e+07. What is the difference between the Emissions(kt) of Fragile and conflict affected situations in 1994 and the Emissions(kt) of Dominica in 1996?
Your answer should be compact. 2.43e+05. What is the difference between the Emissions(kt) in Fragile and conflict affected situations in 1994 and the Emissions(kt) in St. Vincent and the Grenadines in 1996?
Provide a short and direct response. 2.43e+05. What is the difference between the Emissions(kt) of World in 1994 and the Emissions(kt) of Dominica in 1996?
Keep it short and to the point. 2.26e+07. What is the difference between the Emissions(kt) in World in 1994 and the Emissions(kt) in St. Vincent and the Grenadines in 1996?
Provide a succinct answer. 2.26e+07. What is the difference between the Emissions(kt) of Dominica in 1994 and the Emissions(kt) of St. Vincent and the Grenadines in 1996?
Your answer should be compact. -62.34. What is the difference between the Emissions(kt) of Fragile and conflict affected situations in 1995 and the Emissions(kt) of World in 1996?
Make the answer very short. -2.34e+07. What is the difference between the Emissions(kt) of Fragile and conflict affected situations in 1995 and the Emissions(kt) of Dominica in 1996?
Give a very brief answer. 2.45e+05. What is the difference between the Emissions(kt) in Fragile and conflict affected situations in 1995 and the Emissions(kt) in St. Vincent and the Grenadines in 1996?
Ensure brevity in your answer.  2.45e+05. What is the difference between the Emissions(kt) of World in 1995 and the Emissions(kt) of Dominica in 1996?
Ensure brevity in your answer.  2.31e+07. What is the difference between the Emissions(kt) in World in 1995 and the Emissions(kt) in St. Vincent and the Grenadines in 1996?
Ensure brevity in your answer.  2.31e+07. What is the difference between the Emissions(kt) in Dominica in 1995 and the Emissions(kt) in St. Vincent and the Grenadines in 1996?
Ensure brevity in your answer.  -51.34. What is the average Emissions(kt) of Fragile and conflict affected situations per year?
Ensure brevity in your answer.  2.24e+05. What is the average Emissions(kt) of World per year?
Your answer should be very brief. 2.26e+07. What is the average Emissions(kt) in Dominica per year?
Your answer should be compact. 65.09. What is the average Emissions(kt) of St. Vincent and the Grenadines per year?
Provide a succinct answer. 100.38. In the year 1989, what is the difference between the Emissions(kt) in Fragile and conflict affected situations and Emissions(kt) in World?
Provide a succinct answer. -2.19e+07. In the year 1989, what is the difference between the Emissions(kt) in Fragile and conflict affected situations and Emissions(kt) in Dominica?
Offer a terse response. 2.19e+05. In the year 1989, what is the difference between the Emissions(kt) of Fragile and conflict affected situations and Emissions(kt) of St. Vincent and the Grenadines?
Give a very brief answer. 2.19e+05. In the year 1989, what is the difference between the Emissions(kt) in World and Emissions(kt) in Dominica?
Make the answer very short. 2.21e+07. In the year 1989, what is the difference between the Emissions(kt) of World and Emissions(kt) of St. Vincent and the Grenadines?
Keep it short and to the point. 2.21e+07. In the year 1989, what is the difference between the Emissions(kt) of Dominica and Emissions(kt) of St. Vincent and the Grenadines?
Your answer should be compact. -18.34. In the year 1990, what is the difference between the Emissions(kt) of Fragile and conflict affected situations and Emissions(kt) of World?
Give a very brief answer. -2.20e+07. In the year 1990, what is the difference between the Emissions(kt) in Fragile and conflict affected situations and Emissions(kt) in Dominica?
Give a very brief answer. 1.97e+05. In the year 1990, what is the difference between the Emissions(kt) in Fragile and conflict affected situations and Emissions(kt) in St. Vincent and the Grenadines?
Your response must be concise. 1.97e+05. In the year 1990, what is the difference between the Emissions(kt) in World and Emissions(kt) in Dominica?
Make the answer very short. 2.22e+07. In the year 1990, what is the difference between the Emissions(kt) in World and Emissions(kt) in St. Vincent and the Grenadines?
Offer a very short reply. 2.22e+07. In the year 1990, what is the difference between the Emissions(kt) of Dominica and Emissions(kt) of St. Vincent and the Grenadines?
Your answer should be compact. -22. In the year 1991, what is the difference between the Emissions(kt) in Fragile and conflict affected situations and Emissions(kt) in World?
Ensure brevity in your answer.  -2.23e+07. In the year 1991, what is the difference between the Emissions(kt) of Fragile and conflict affected situations and Emissions(kt) of Dominica?
Give a very brief answer. 2.04e+05. In the year 1991, what is the difference between the Emissions(kt) of Fragile and conflict affected situations and Emissions(kt) of St. Vincent and the Grenadines?
Your answer should be very brief. 2.04e+05. In the year 1991, what is the difference between the Emissions(kt) of World and Emissions(kt) of Dominica?
Your answer should be compact. 2.25e+07. In the year 1991, what is the difference between the Emissions(kt) in World and Emissions(kt) in St. Vincent and the Grenadines?
Ensure brevity in your answer.  2.25e+07. In the year 1991, what is the difference between the Emissions(kt) in Dominica and Emissions(kt) in St. Vincent and the Grenadines?
Give a very brief answer. -18.34. In the year 1992, what is the difference between the Emissions(kt) in Fragile and conflict affected situations and Emissions(kt) in World?
Provide a short and direct response. -2.20e+07. In the year 1992, what is the difference between the Emissions(kt) of Fragile and conflict affected situations and Emissions(kt) of Dominica?
Make the answer very short. 2.19e+05. In the year 1992, what is the difference between the Emissions(kt) in Fragile and conflict affected situations and Emissions(kt) in St. Vincent and the Grenadines?
Your response must be concise. 2.19e+05. In the year 1992, what is the difference between the Emissions(kt) in World and Emissions(kt) in Dominica?
Your answer should be compact. 2.22e+07. In the year 1992, what is the difference between the Emissions(kt) in World and Emissions(kt) in St. Vincent and the Grenadines?
Provide a succinct answer. 2.22e+07. In the year 1992, what is the difference between the Emissions(kt) of Dominica and Emissions(kt) of St. Vincent and the Grenadines?
Offer a terse response. -25.67. In the year 1993, what is the difference between the Emissions(kt) in Fragile and conflict affected situations and Emissions(kt) in World?
Your answer should be very brief. -2.20e+07. In the year 1993, what is the difference between the Emissions(kt) of Fragile and conflict affected situations and Emissions(kt) of Dominica?
Provide a short and direct response. 2.22e+05. In the year 1993, what is the difference between the Emissions(kt) in Fragile and conflict affected situations and Emissions(kt) in St. Vincent and the Grenadines?
Give a very brief answer. 2.22e+05. In the year 1993, what is the difference between the Emissions(kt) in World and Emissions(kt) in Dominica?
Offer a terse response. 2.22e+07. In the year 1993, what is the difference between the Emissions(kt) in World and Emissions(kt) in St. Vincent and the Grenadines?
Provide a succinct answer. 2.22e+07. In the year 1993, what is the difference between the Emissions(kt) of Dominica and Emissions(kt) of St. Vincent and the Grenadines?
Give a very brief answer. -40.34. In the year 1994, what is the difference between the Emissions(kt) of Fragile and conflict affected situations and Emissions(kt) of World?
Make the answer very short. -2.24e+07. In the year 1994, what is the difference between the Emissions(kt) of Fragile and conflict affected situations and Emissions(kt) of Dominica?
Your response must be concise. 2.43e+05. In the year 1994, what is the difference between the Emissions(kt) in Fragile and conflict affected situations and Emissions(kt) in St. Vincent and the Grenadines?
Your response must be concise. 2.43e+05. In the year 1994, what is the difference between the Emissions(kt) in World and Emissions(kt) in Dominica?
Your answer should be very brief. 2.26e+07. In the year 1994, what is the difference between the Emissions(kt) of World and Emissions(kt) of St. Vincent and the Grenadines?
Make the answer very short. 2.26e+07. In the year 1994, what is the difference between the Emissions(kt) in Dominica and Emissions(kt) in St. Vincent and the Grenadines?
Keep it short and to the point. -51.34. In the year 1995, what is the difference between the Emissions(kt) in Fragile and conflict affected situations and Emissions(kt) in World?
Your response must be concise. -2.29e+07. In the year 1995, what is the difference between the Emissions(kt) in Fragile and conflict affected situations and Emissions(kt) in Dominica?
Ensure brevity in your answer.  2.45e+05. In the year 1995, what is the difference between the Emissions(kt) of Fragile and conflict affected situations and Emissions(kt) of St. Vincent and the Grenadines?
Ensure brevity in your answer.  2.45e+05. In the year 1995, what is the difference between the Emissions(kt) in World and Emissions(kt) in Dominica?
Offer a terse response. 2.31e+07. In the year 1995, what is the difference between the Emissions(kt) in World and Emissions(kt) in St. Vincent and the Grenadines?
Make the answer very short. 2.31e+07. In the year 1995, what is the difference between the Emissions(kt) of Dominica and Emissions(kt) of St. Vincent and the Grenadines?
Your answer should be compact. -47.67. In the year 1996, what is the difference between the Emissions(kt) of Fragile and conflict affected situations and Emissions(kt) of World?
Your response must be concise. -2.34e+07. In the year 1996, what is the difference between the Emissions(kt) of Fragile and conflict affected situations and Emissions(kt) of Dominica?
Give a very brief answer. 2.42e+05. In the year 1996, what is the difference between the Emissions(kt) of Fragile and conflict affected situations and Emissions(kt) of St. Vincent and the Grenadines?
Ensure brevity in your answer.  2.42e+05. In the year 1996, what is the difference between the Emissions(kt) in World and Emissions(kt) in Dominica?
Provide a short and direct response. 2.37e+07. In the year 1996, what is the difference between the Emissions(kt) in World and Emissions(kt) in St. Vincent and the Grenadines?
Offer a very short reply. 2.37e+07. In the year 1996, what is the difference between the Emissions(kt) in Dominica and Emissions(kt) in St. Vincent and the Grenadines?
Offer a very short reply. -58.67. What is the ratio of the Emissions(kt) in Fragile and conflict affected situations in 1989 to that in 1990?
Make the answer very short. 1.11. What is the ratio of the Emissions(kt) of Dominica in 1989 to that in 1990?
Your response must be concise. 1. What is the ratio of the Emissions(kt) of St. Vincent and the Grenadines in 1989 to that in 1990?
Your answer should be compact. 0.95. What is the ratio of the Emissions(kt) of Fragile and conflict affected situations in 1989 to that in 1991?
Provide a succinct answer. 1.07. What is the ratio of the Emissions(kt) of World in 1989 to that in 1991?
Make the answer very short. 0.98. What is the ratio of the Emissions(kt) in St. Vincent and the Grenadines in 1989 to that in 1991?
Provide a succinct answer. 1. What is the ratio of the Emissions(kt) of Fragile and conflict affected situations in 1989 to that in 1992?
Give a very brief answer. 1. What is the ratio of the Emissions(kt) of St. Vincent and the Grenadines in 1989 to that in 1992?
Your answer should be compact. 0.91. What is the ratio of the Emissions(kt) in Fragile and conflict affected situations in 1989 to that in 1993?
Offer a terse response. 0.99. What is the ratio of the Emissions(kt) in Fragile and conflict affected situations in 1989 to that in 1994?
Make the answer very short. 0.9. What is the ratio of the Emissions(kt) in World in 1989 to that in 1994?
Provide a succinct answer. 0.98. What is the ratio of the Emissions(kt) in Dominica in 1989 to that in 1994?
Give a very brief answer. 0.84. What is the ratio of the Emissions(kt) of St. Vincent and the Grenadines in 1989 to that in 1994?
Give a very brief answer. 0.64. What is the ratio of the Emissions(kt) in Fragile and conflict affected situations in 1989 to that in 1995?
Give a very brief answer. 0.89. What is the ratio of the Emissions(kt) of World in 1989 to that in 1995?
Make the answer very short. 0.96. What is the ratio of the Emissions(kt) of Dominica in 1989 to that in 1995?
Offer a very short reply. 0.73. What is the ratio of the Emissions(kt) in St. Vincent and the Grenadines in 1989 to that in 1995?
Provide a succinct answer. 0.6. What is the ratio of the Emissions(kt) of Fragile and conflict affected situations in 1989 to that in 1996?
Offer a terse response. 0.9. What is the ratio of the Emissions(kt) of World in 1989 to that in 1996?
Give a very brief answer. 0.93. What is the ratio of the Emissions(kt) of St. Vincent and the Grenadines in 1989 to that in 1996?
Make the answer very short. 0.58. What is the ratio of the Emissions(kt) in Fragile and conflict affected situations in 1990 to that in 1991?
Your answer should be compact. 0.96. What is the ratio of the Emissions(kt) of World in 1990 to that in 1991?
Give a very brief answer. 0.99. What is the ratio of the Emissions(kt) of St. Vincent and the Grenadines in 1990 to that in 1991?
Provide a succinct answer. 1.05. What is the ratio of the Emissions(kt) in Fragile and conflict affected situations in 1990 to that in 1992?
Ensure brevity in your answer.  0.9. What is the ratio of the Emissions(kt) of Dominica in 1990 to that in 1992?
Your answer should be very brief. 1. What is the ratio of the Emissions(kt) of St. Vincent and the Grenadines in 1990 to that in 1992?
Make the answer very short. 0.96. What is the ratio of the Emissions(kt) of Fragile and conflict affected situations in 1990 to that in 1993?
Keep it short and to the point. 0.89. What is the ratio of the Emissions(kt) of Dominica in 1990 to that in 1993?
Make the answer very short. 0.94. What is the ratio of the Emissions(kt) in St. Vincent and the Grenadines in 1990 to that in 1993?
Provide a short and direct response. 0.79. What is the ratio of the Emissions(kt) in Fragile and conflict affected situations in 1990 to that in 1994?
Offer a very short reply. 0.81. What is the ratio of the Emissions(kt) in World in 1990 to that in 1994?
Offer a terse response. 0.98. What is the ratio of the Emissions(kt) of Dominica in 1990 to that in 1994?
Make the answer very short. 0.84. What is the ratio of the Emissions(kt) in St. Vincent and the Grenadines in 1990 to that in 1994?
Offer a very short reply. 0.67. What is the ratio of the Emissions(kt) of Fragile and conflict affected situations in 1990 to that in 1995?
Ensure brevity in your answer.  0.8. What is the ratio of the Emissions(kt) in World in 1990 to that in 1995?
Give a very brief answer. 0.96. What is the ratio of the Emissions(kt) in Dominica in 1990 to that in 1995?
Make the answer very short. 0.73. What is the ratio of the Emissions(kt) of St. Vincent and the Grenadines in 1990 to that in 1995?
Keep it short and to the point. 0.63. What is the ratio of the Emissions(kt) of Fragile and conflict affected situations in 1990 to that in 1996?
Your response must be concise. 0.81. What is the ratio of the Emissions(kt) of World in 1990 to that in 1996?
Make the answer very short. 0.94. What is the ratio of the Emissions(kt) of Dominica in 1990 to that in 1996?
Keep it short and to the point. 0.8. What is the ratio of the Emissions(kt) of St. Vincent and the Grenadines in 1990 to that in 1996?
Make the answer very short. 0.61. What is the ratio of the Emissions(kt) in Fragile and conflict affected situations in 1991 to that in 1992?
Provide a succinct answer. 0.93. What is the ratio of the Emissions(kt) of World in 1991 to that in 1992?
Offer a very short reply. 1.01. What is the ratio of the Emissions(kt) in St. Vincent and the Grenadines in 1991 to that in 1992?
Provide a short and direct response. 0.91. What is the ratio of the Emissions(kt) in Fragile and conflict affected situations in 1991 to that in 1993?
Make the answer very short. 0.92. What is the ratio of the Emissions(kt) in World in 1991 to that in 1993?
Your response must be concise. 1.01. What is the ratio of the Emissions(kt) of Fragile and conflict affected situations in 1991 to that in 1994?
Offer a terse response. 0.84. What is the ratio of the Emissions(kt) in World in 1991 to that in 1994?
Keep it short and to the point. 0.99. What is the ratio of the Emissions(kt) in Dominica in 1991 to that in 1994?
Ensure brevity in your answer.  0.84. What is the ratio of the Emissions(kt) in St. Vincent and the Grenadines in 1991 to that in 1994?
Offer a terse response. 0.64. What is the ratio of the Emissions(kt) of Fragile and conflict affected situations in 1991 to that in 1995?
Offer a very short reply. 0.83. What is the ratio of the Emissions(kt) in World in 1991 to that in 1995?
Your answer should be compact. 0.97. What is the ratio of the Emissions(kt) of Dominica in 1991 to that in 1995?
Provide a succinct answer. 0.73. What is the ratio of the Emissions(kt) of Fragile and conflict affected situations in 1991 to that in 1996?
Make the answer very short. 0.84. What is the ratio of the Emissions(kt) of World in 1991 to that in 1996?
Your answer should be compact. 0.95. What is the ratio of the Emissions(kt) in St. Vincent and the Grenadines in 1991 to that in 1996?
Offer a very short reply. 0.58. What is the ratio of the Emissions(kt) of Dominica in 1992 to that in 1993?
Give a very brief answer. 0.94. What is the ratio of the Emissions(kt) in St. Vincent and the Grenadines in 1992 to that in 1993?
Offer a very short reply. 0.82. What is the ratio of the Emissions(kt) of Fragile and conflict affected situations in 1992 to that in 1994?
Offer a terse response. 0.9. What is the ratio of the Emissions(kt) of World in 1992 to that in 1994?
Your response must be concise. 0.98. What is the ratio of the Emissions(kt) of Dominica in 1992 to that in 1994?
Make the answer very short. 0.84. What is the ratio of the Emissions(kt) in St. Vincent and the Grenadines in 1992 to that in 1994?
Make the answer very short. 0.7. What is the ratio of the Emissions(kt) of Fragile and conflict affected situations in 1992 to that in 1995?
Your response must be concise. 0.89. What is the ratio of the Emissions(kt) in World in 1992 to that in 1995?
Provide a short and direct response. 0.96. What is the ratio of the Emissions(kt) in Dominica in 1992 to that in 1995?
Offer a terse response. 0.73. What is the ratio of the Emissions(kt) of St. Vincent and the Grenadines in 1992 to that in 1995?
Your answer should be compact. 0.66. What is the ratio of the Emissions(kt) in Fragile and conflict affected situations in 1992 to that in 1996?
Provide a succinct answer. 0.91. What is the ratio of the Emissions(kt) of World in 1992 to that in 1996?
Provide a short and direct response. 0.94. What is the ratio of the Emissions(kt) of St. Vincent and the Grenadines in 1992 to that in 1996?
Your answer should be very brief. 0.64. What is the ratio of the Emissions(kt) in Fragile and conflict affected situations in 1993 to that in 1994?
Ensure brevity in your answer.  0.91. What is the ratio of the Emissions(kt) in World in 1993 to that in 1994?
Give a very brief answer. 0.98. What is the ratio of the Emissions(kt) of Dominica in 1993 to that in 1994?
Offer a very short reply. 0.89. What is the ratio of the Emissions(kt) of St. Vincent and the Grenadines in 1993 to that in 1994?
Provide a succinct answer. 0.85. What is the ratio of the Emissions(kt) of Fragile and conflict affected situations in 1993 to that in 1995?
Keep it short and to the point. 0.9. What is the ratio of the Emissions(kt) in World in 1993 to that in 1995?
Your answer should be very brief. 0.96. What is the ratio of the Emissions(kt) of Dominica in 1993 to that in 1995?
Offer a terse response. 0.77. What is the ratio of the Emissions(kt) in St. Vincent and the Grenadines in 1993 to that in 1995?
Offer a very short reply. 0.8. What is the ratio of the Emissions(kt) in Fragile and conflict affected situations in 1993 to that in 1996?
Make the answer very short. 0.92. What is the ratio of the Emissions(kt) in World in 1993 to that in 1996?
Ensure brevity in your answer.  0.94. What is the ratio of the Emissions(kt) in Dominica in 1993 to that in 1996?
Offer a terse response. 0.85. What is the ratio of the Emissions(kt) in Fragile and conflict affected situations in 1994 to that in 1995?
Provide a succinct answer. 0.99. What is the ratio of the Emissions(kt) of World in 1994 to that in 1995?
Make the answer very short. 0.98. What is the ratio of the Emissions(kt) of Dominica in 1994 to that in 1995?
Keep it short and to the point. 0.86. What is the ratio of the Emissions(kt) of St. Vincent and the Grenadines in 1994 to that in 1995?
Offer a very short reply. 0.94. What is the ratio of the Emissions(kt) in World in 1994 to that in 1996?
Keep it short and to the point. 0.96. What is the ratio of the Emissions(kt) of Dominica in 1994 to that in 1996?
Your response must be concise. 0.95. What is the ratio of the Emissions(kt) of Fragile and conflict affected situations in 1995 to that in 1996?
Make the answer very short. 1.02. What is the ratio of the Emissions(kt) in World in 1995 to that in 1996?
Provide a succinct answer. 0.98. What is the ratio of the Emissions(kt) in Dominica in 1995 to that in 1996?
Your answer should be very brief. 1.1. What is the ratio of the Emissions(kt) in St. Vincent and the Grenadines in 1995 to that in 1996?
Ensure brevity in your answer.  0.97. What is the difference between the highest and the second highest Emissions(kt) in Fragile and conflict affected situations?
Offer a very short reply. 2730.08. What is the difference between the highest and the second highest Emissions(kt) of World?
Your response must be concise. 5.53e+05. What is the difference between the highest and the second highest Emissions(kt) in Dominica?
Your answer should be very brief. 7.33. What is the difference between the highest and the second highest Emissions(kt) in St. Vincent and the Grenadines?
Your answer should be compact. 3.67. What is the difference between the highest and the lowest Emissions(kt) of Fragile and conflict affected situations?
Provide a short and direct response. 4.87e+04. What is the difference between the highest and the lowest Emissions(kt) in World?
Your answer should be compact. 1.55e+06. What is the difference between the highest and the lowest Emissions(kt) of Dominica?
Your response must be concise. 22. What is the difference between the highest and the lowest Emissions(kt) of St. Vincent and the Grenadines?
Offer a very short reply. 55.01. 